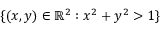Convert formula to latex. <formula><loc_0><loc_0><loc_500><loc_500>\{ ( x , y ) \in \mathbb { R } ^ { 2 } \colon x ^ { 2 } + y ^ { 2 } > 1 \}</formula> 